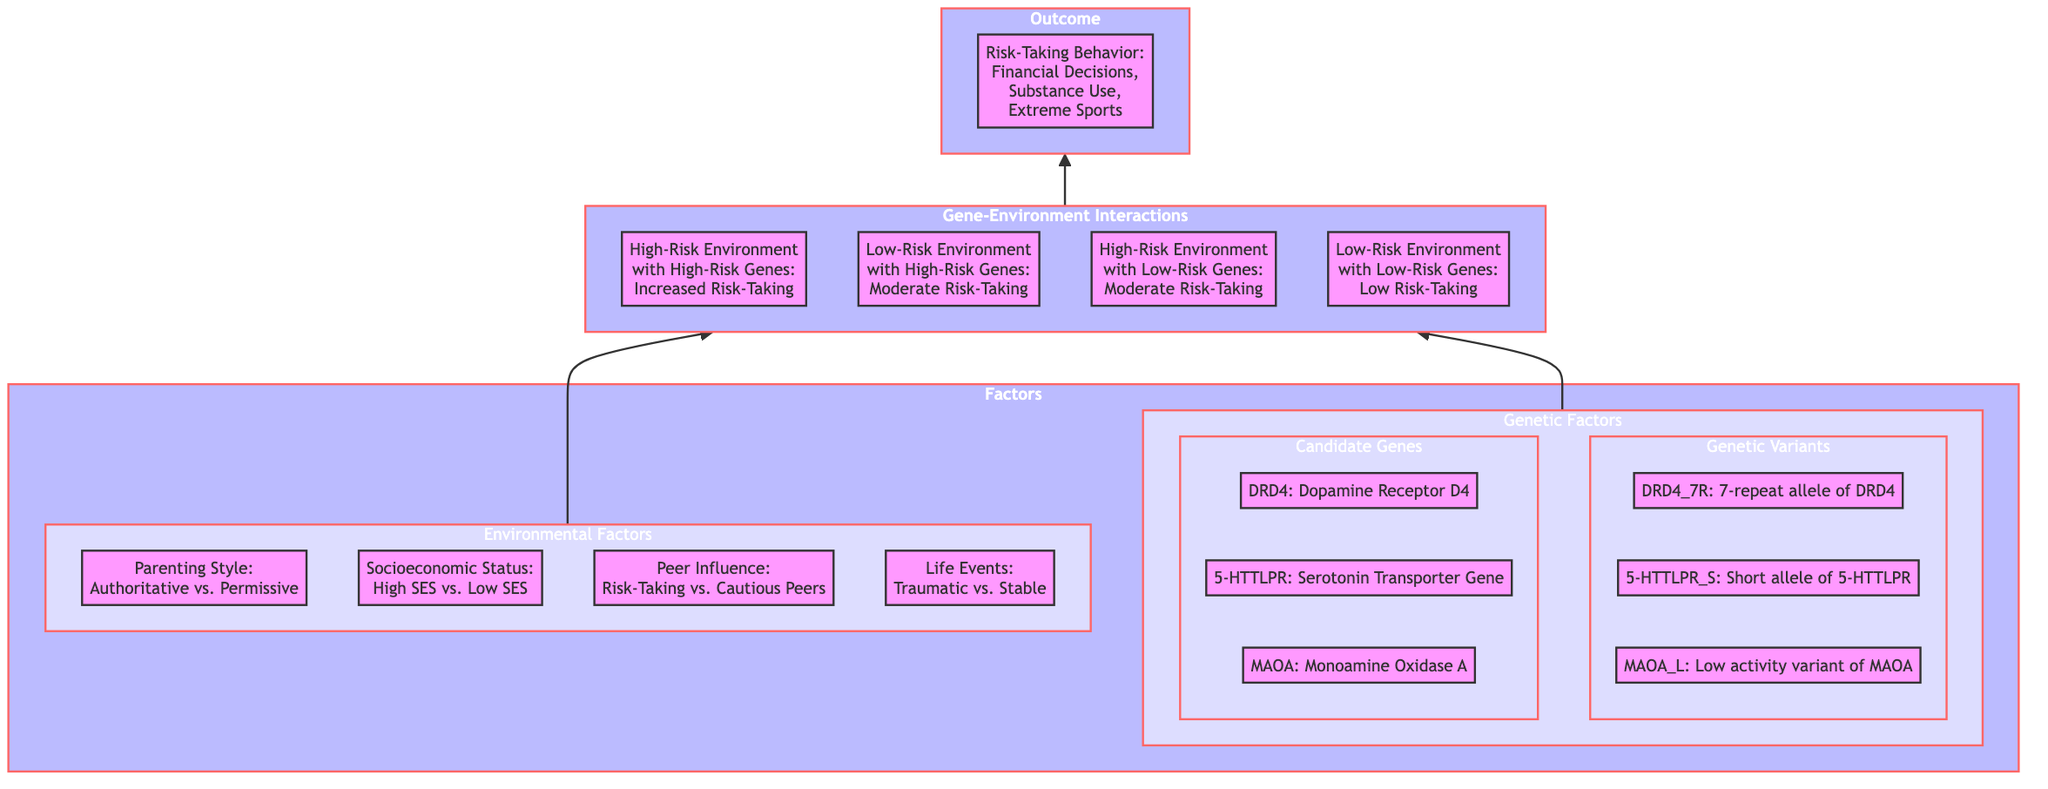What are the two categories of factors influencing risk-taking behavior? The factors influencing risk-taking behavior are categorized into Environmental Factors and Genetic Factors as shown in the diagram.
Answer: Environmental Factors and Genetic Factors Which genetic candidate gene is associated with the serotonin transporter? The diagram specifies 5-HTTLPR as the serotonin transporter gene, therefore it is the associated candidate gene.
Answer: 5-HTTLPR How many subcategories are under Genetic Factors? The Genetic Factors category in the diagram has two subcategories: Candidate Genes and Genetic Variants, totaling two subcategories.
Answer: 2 What outcome is associated with the high-risk environment and high-risk genes interaction? The diagram indicates that the outcome associated with high-risk environment and high-risk genes is increased risk-taking.
Answer: Increased Risk-Taking In a low-risk environment with low-risk genes, what is the expected risk-taking level? According to the diagram, the expected risk-taking level in a low-risk environment with low-risk genes is low risk-taking.
Answer: Low Risk-Taking What are the four types of life events categorized in the environmental factors? The environmental factors section of the diagram presents Life Events as classified into Traumatic Events and Stable Life Events, indicating two types total.
Answer: Traumatic Events and Stable Life Events Which interaction results in moderate risk-taking? Both Low-Risk Environment with High-Risk Genes and High-Risk Environment with Low-Risk Genes lead to moderate risk-taking as shown in the diagram highlighting two distinct interactions.
Answer: Moderate Risk-Taking What is the relationship between genetic variants and risk-taking behavior? The diagram illustrates that genetic variants interact with environmental factors, which subsequently influences risk-taking behavior outcomes. Therefore, there is a direct relationship shown in the flow.
Answer: Influences Risk-Taking Behavior How many different peer influences are identified in environmental factors? The diagram shows two peer influences: Risk-Taking Peers and Cautious Peers, indicating a total of two distinct influences.
Answer: 2 